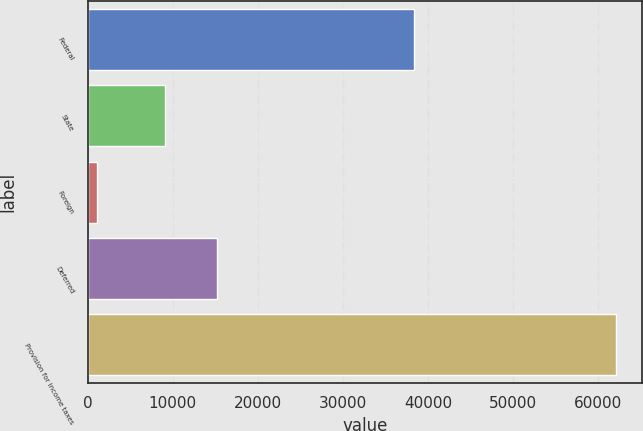<chart> <loc_0><loc_0><loc_500><loc_500><bar_chart><fcel>Federal<fcel>State<fcel>Foreign<fcel>Deferred<fcel>Provision for income taxes<nl><fcel>38294<fcel>9099<fcel>1113<fcel>15191.8<fcel>62041<nl></chart> 